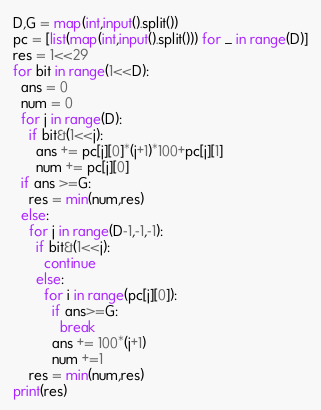<code> <loc_0><loc_0><loc_500><loc_500><_Python_>D,G = map(int,input().split())
pc = [list(map(int,input().split())) for _ in range(D)]
res = 1<<29
for bit in range(1<<D):
  ans = 0
  num = 0
  for j in range(D):
    if bit&(1<<j):
      ans += pc[j][0]*(j+1)*100+pc[j][1]
      num += pc[j][0]
  if ans >=G:
    res = min(num,res)
  else:
    for j in range(D-1,-1,-1):
      if bit&(1<<j):
        continue
      else:
        for i in range(pc[j][0]):
          if ans>=G:
            break
          ans += 100*(j+1)
          num +=1
    res = min(num,res)
print(res)</code> 